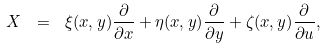<formula> <loc_0><loc_0><loc_500><loc_500>X \ = \ \xi ( x , y ) \frac { \partial } { \partial x } + \eta ( x , y ) \frac { \partial } { \partial y } + \zeta ( x , y ) \frac { \partial } { \partial u } ,</formula> 